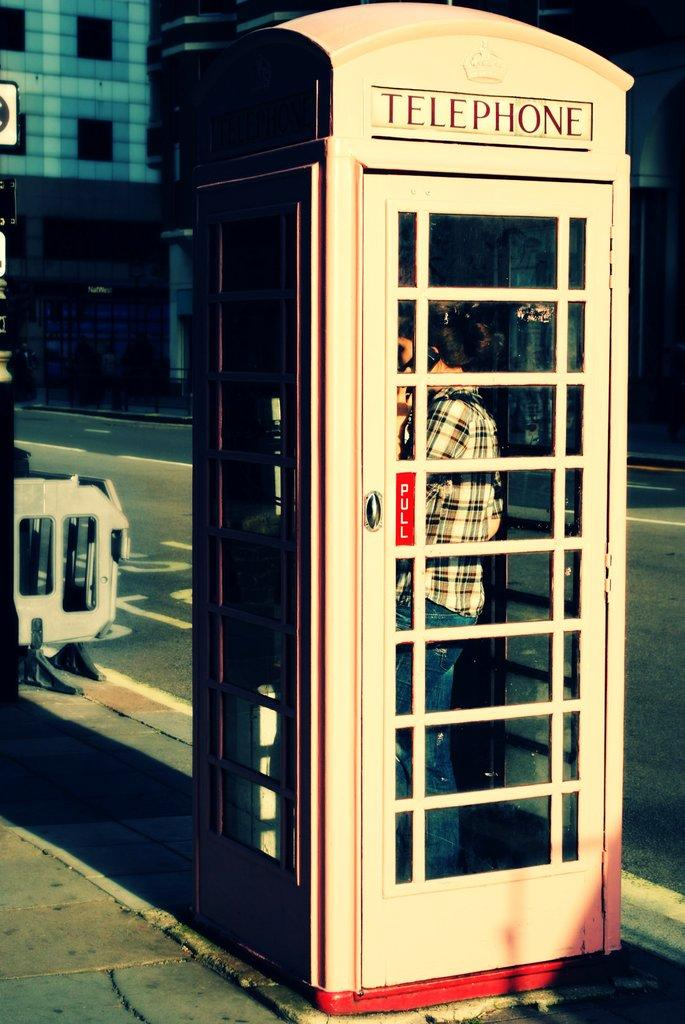What structure is present in the image? There is a telephone booth in the image. Who or what is inside the telephone booth? There is a person inside the telephone booth. What can be seen in the background of the image? There is a building in the background of the image. What type of lettuce is being used to fold the person inside the telephone booth? There is no lettuce or folding action present in the image; it features a person inside a telephone booth with a building in the background. 